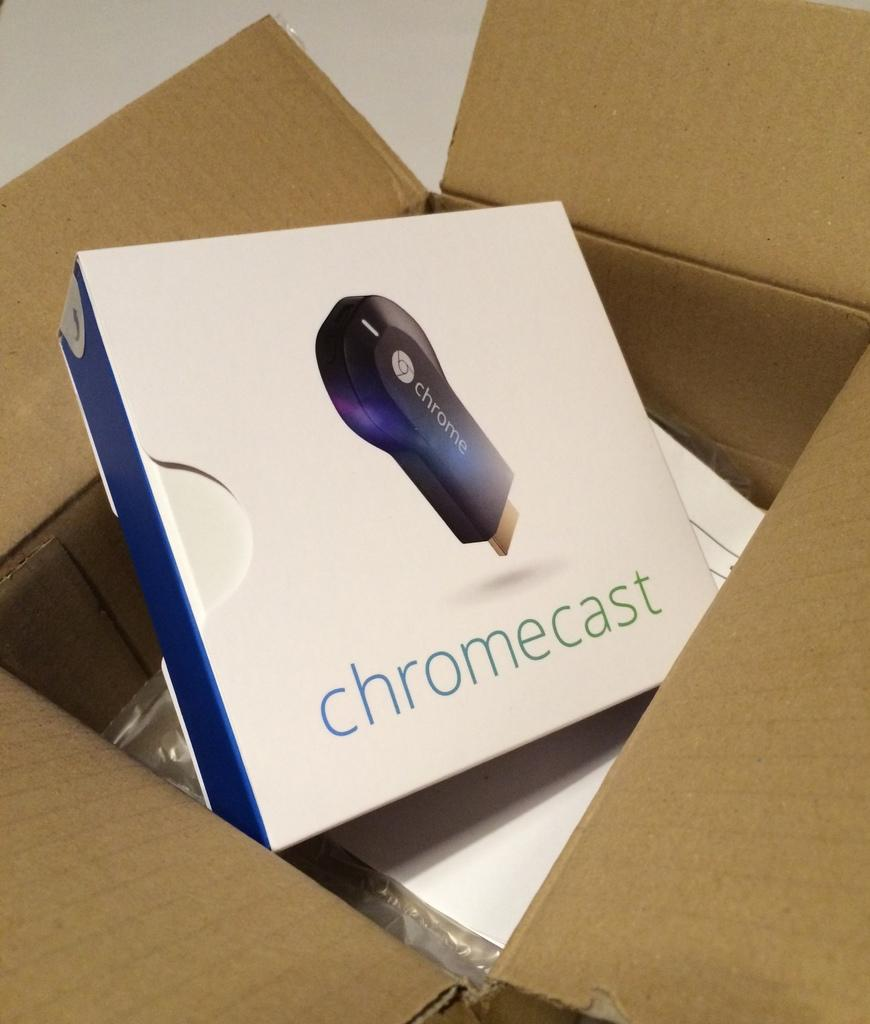<image>
Summarize the visual content of the image. a box for Chrome Cast is sitting in an open cardboard box 